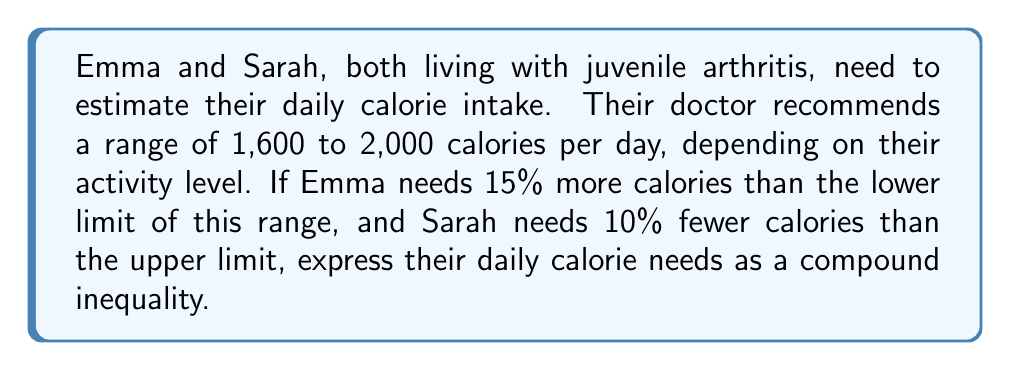Solve this math problem. Let's approach this step-by-step:

1) First, let's identify the given range:
   Lower limit: 1,600 calories
   Upper limit: 2,000 calories

2) For Emma:
   She needs 15% more than the lower limit.
   $15\% \text{ of } 1,600 = 0.15 \times 1,600 = 240$ calories
   Emma's calorie need = $1,600 + 240 = 1,840$ calories

3) For Sarah:
   She needs 10% less than the upper limit.
   $10\% \text{ of } 2,000 = 0.10 \times 2,000 = 200$ calories
   Sarah's calorie need = $2,000 - 200 = 1,800$ calories

4) Now, we can express this as a compound inequality:
   $1,840 \leq x \leq 1,800$

   Where $x$ represents the daily calorie intake for either Emma or Sarah.

5) However, this inequality is impossible to satisfy because 1,840 is greater than 1,800. In reality, their needs overlap, so we should express it as:

   $1,800 \leq x \leq 1,840$

This represents the range of calories that would satisfy both Emma's and Sarah's needs.
Answer: $1,800 \leq x \leq 1,840$ 